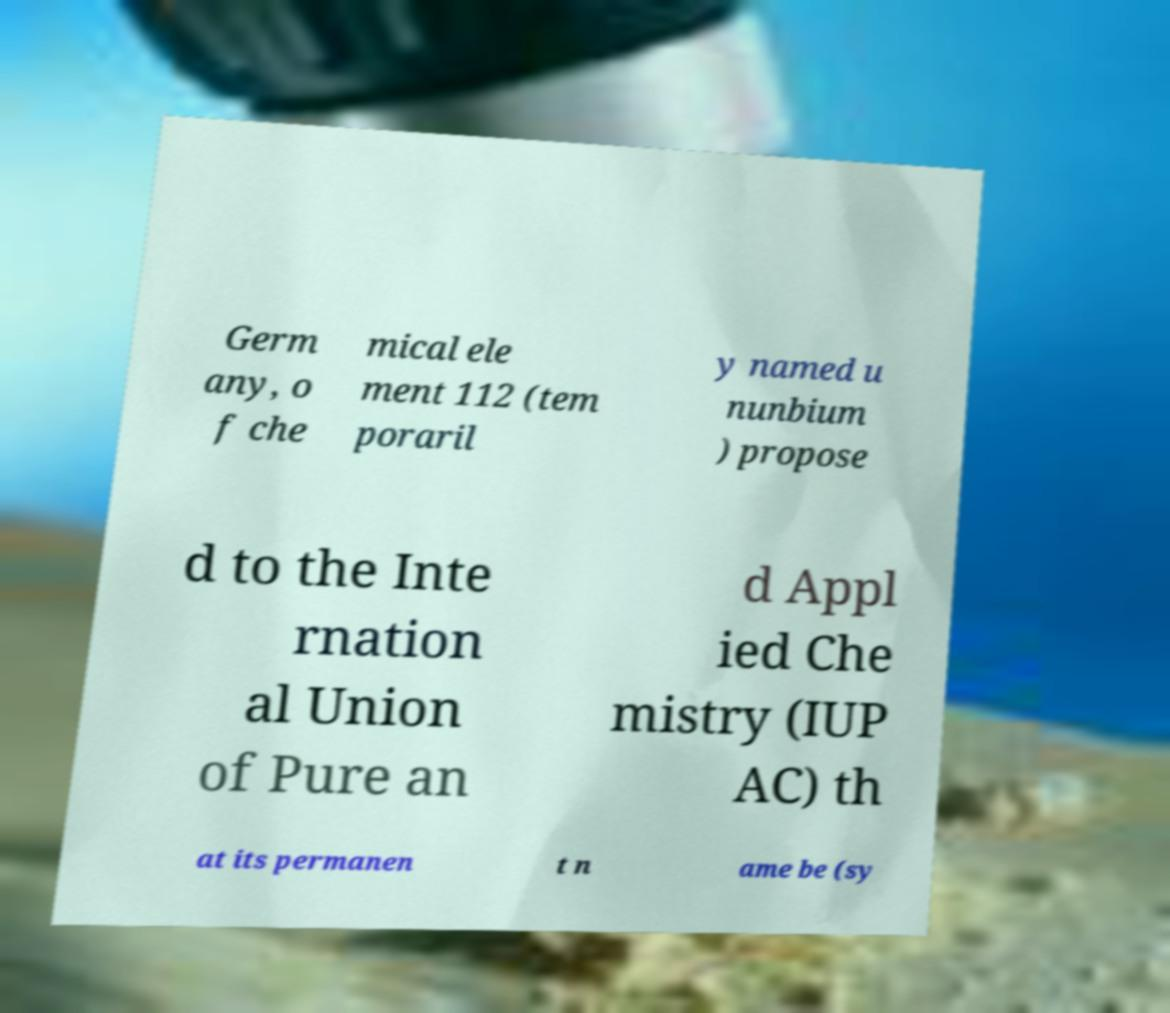Could you extract and type out the text from this image? Germ any, o f che mical ele ment 112 (tem poraril y named u nunbium ) propose d to the Inte rnation al Union of Pure an d Appl ied Che mistry (IUP AC) th at its permanen t n ame be (sy 